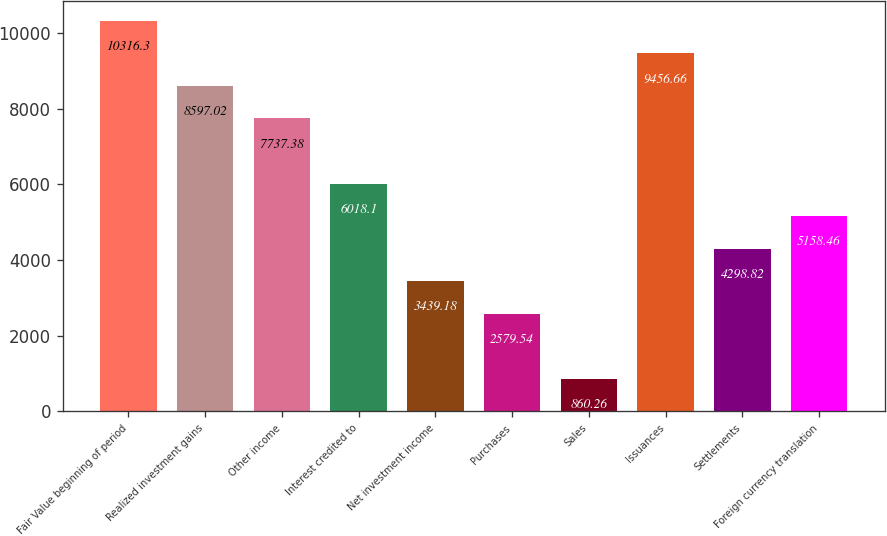Convert chart. <chart><loc_0><loc_0><loc_500><loc_500><bar_chart><fcel>Fair Value beginning of period<fcel>Realized investment gains<fcel>Other income<fcel>Interest credited to<fcel>Net investment income<fcel>Purchases<fcel>Sales<fcel>Issuances<fcel>Settlements<fcel>Foreign currency translation<nl><fcel>10316.3<fcel>8597.02<fcel>7737.38<fcel>6018.1<fcel>3439.18<fcel>2579.54<fcel>860.26<fcel>9456.66<fcel>4298.82<fcel>5158.46<nl></chart> 